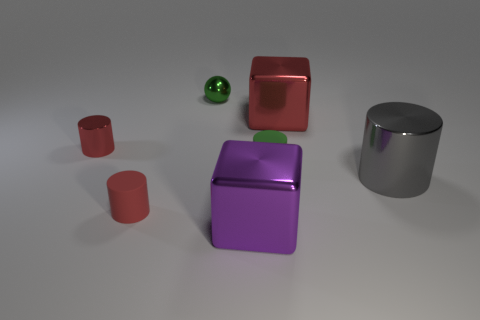What number of metal things are either red cylinders or cylinders?
Make the answer very short. 2. There is a metal cylinder that is the same size as the green metallic ball; what color is it?
Provide a succinct answer. Red. How many large gray metal things are the same shape as the green matte object?
Your answer should be compact. 1. What number of cylinders are either large red metal objects or green rubber objects?
Your response must be concise. 1. There is a red object that is on the right side of the big purple object; does it have the same shape as the rubber thing that is to the right of the purple metal block?
Your answer should be very brief. No. What material is the green cylinder?
Make the answer very short. Rubber. There is a thing that is the same color as the tiny shiny ball; what shape is it?
Offer a terse response. Cylinder. What number of green matte cylinders have the same size as the green metal thing?
Your answer should be very brief. 1. What number of things are big blocks to the left of the red metallic block or objects behind the purple thing?
Ensure brevity in your answer.  7. Is the tiny green cylinder that is behind the gray shiny cylinder made of the same material as the tiny green object that is on the left side of the purple cube?
Offer a very short reply. No. 